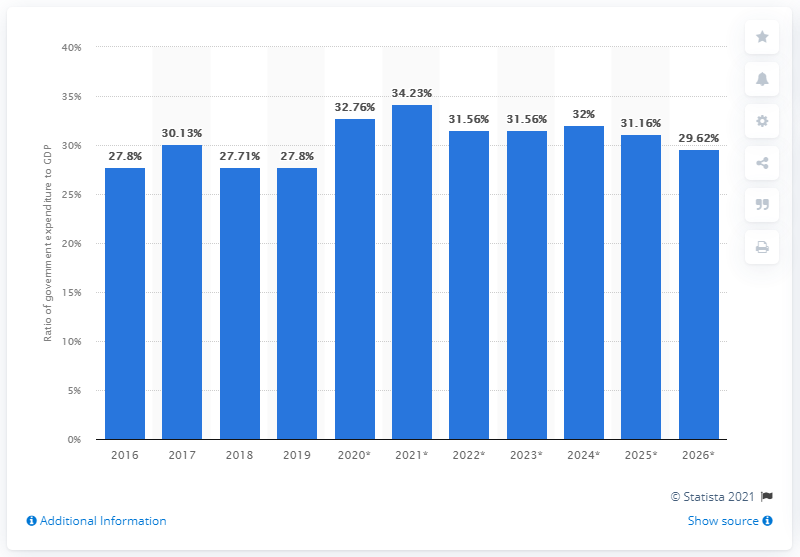Point out several critical features in this image. In 2019, government expenditure in Malawi accounted for 27.8% of the country's gross domestic product. 